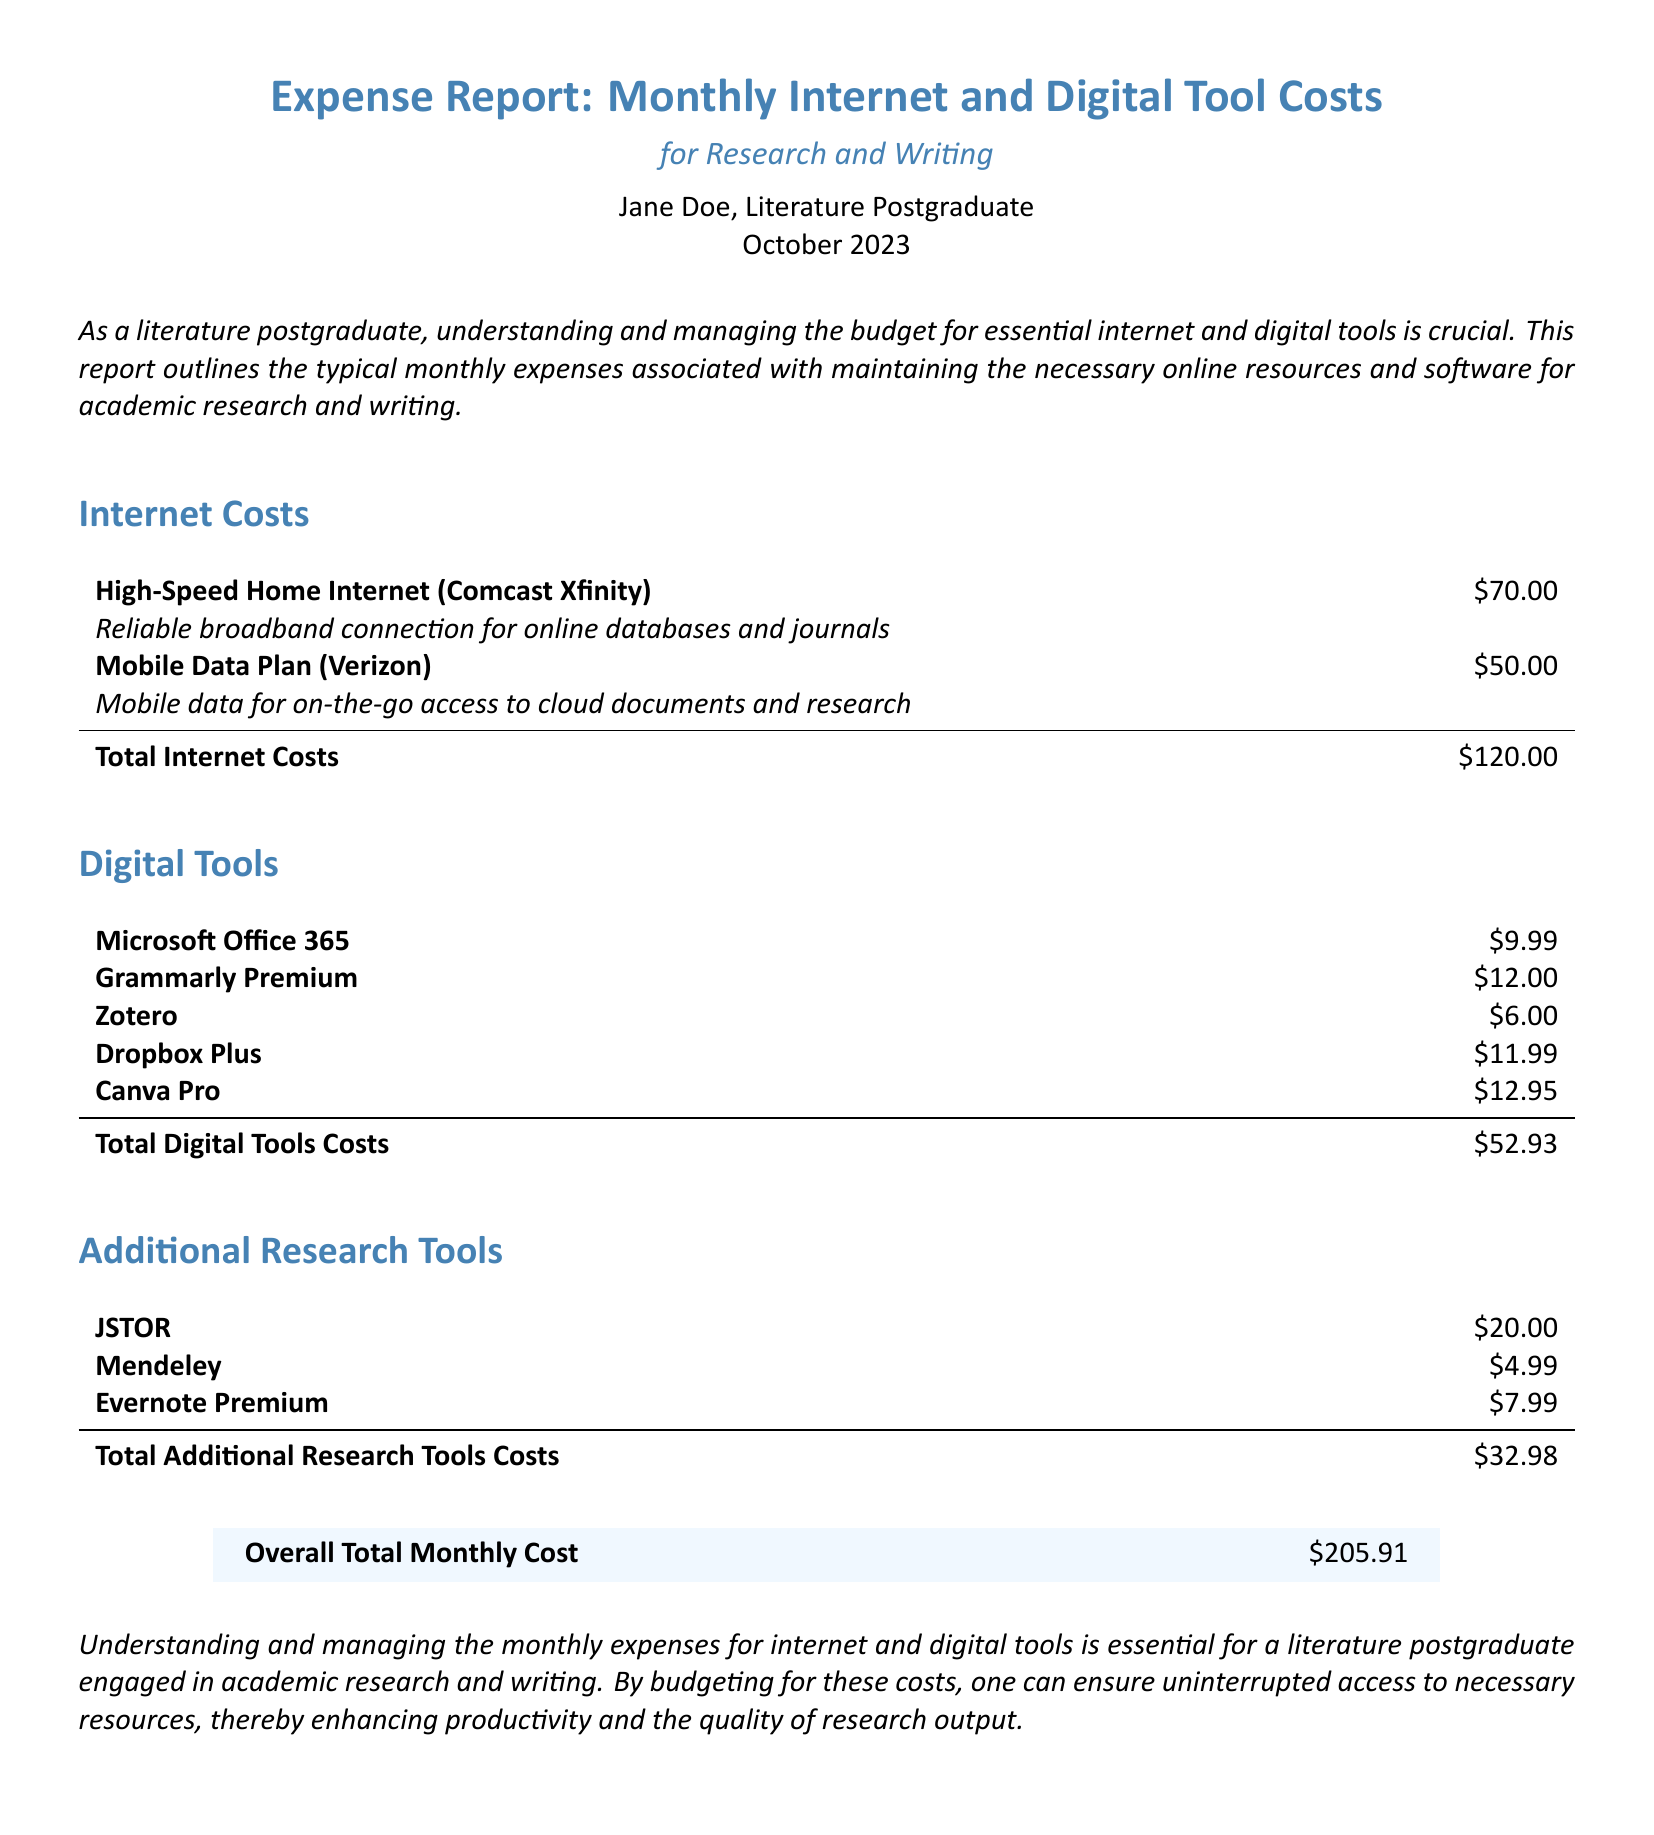What are the total internet costs? The total for internet costs is calculated by adding the individual amounts for high-speed home internet and mobile data plan, which are $70.00 + $50.00.
Answer: $120.00 How much does Grammarly Premium cost? The cost of Grammarly Premium is specifically listed in the digital tools section of the document.
Answer: $12.00 What is the total cost for additional research tools? This is the sum of the individual costs for JSTOR, Mendeley, and Evernote Premium, totaling $20.00 + $4.99 + $7.99.
Answer: $32.98 Which internet provider is used for the high-speed home internet? The document specifies the provider for high-speed home internet in the internet costs section.
Answer: Comcast Xfinity What is the overall total monthly cost? This is located at the end of the report and represents the sum of all costs detailed throughout the document.
Answer: $205.91 How many digital tools are listed in the report? The total is determined by counting the individual entries in the digital tools section of the report.
Answer: 5 What is the purpose of this expense report? The document summarizes the monthly expenses for internet and digital tools essential for a specific group of users.
Answer: For Research and Writing What amount is assigned to Dropbox Plus in the digital tools section? The cost associated with Dropbox Plus can be found in the digital tools section.
Answer: $11.99 How much does Mendeley cost monthly? The monthly cost for Mendeley is specifically indicated in the additional research tools section.
Answer: $4.99 